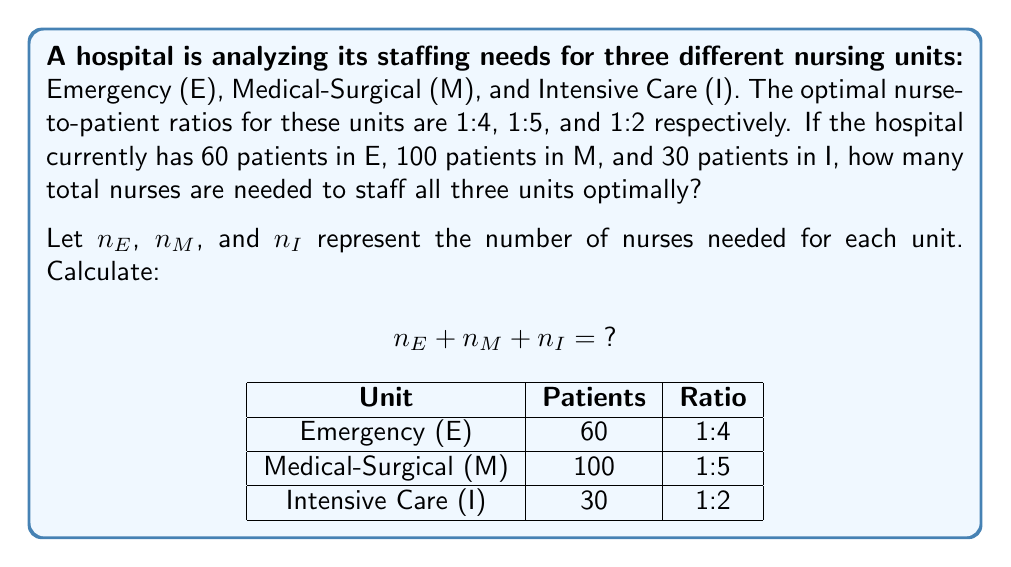Can you solve this math problem? Let's approach this step-by-step:

1) For the Emergency unit (E):
   - Ratio is 1:4 (1 nurse for every 4 patients)
   - Number of patients = 60
   - Number of nurses needed: $n_E = 60 \div 4 = 15$

2) For the Medical-Surgical unit (M):
   - Ratio is 1:5 (1 nurse for every 5 patients)
   - Number of patients = 100
   - Number of nurses needed: $n_M = 100 \div 5 = 20$

3) For the Intensive Care unit (I):
   - Ratio is 1:2 (1 nurse for every 2 patients)
   - Number of patients = 30
   - Number of nurses needed: $n_I = 30 \div 2 = 15$

4) Total number of nurses needed:
   $n_E + n_M + n_I = 15 + 20 + 15 = 50$

Therefore, the hospital needs a total of 50 nurses to staff all three units optimally.
Answer: 50 nurses 